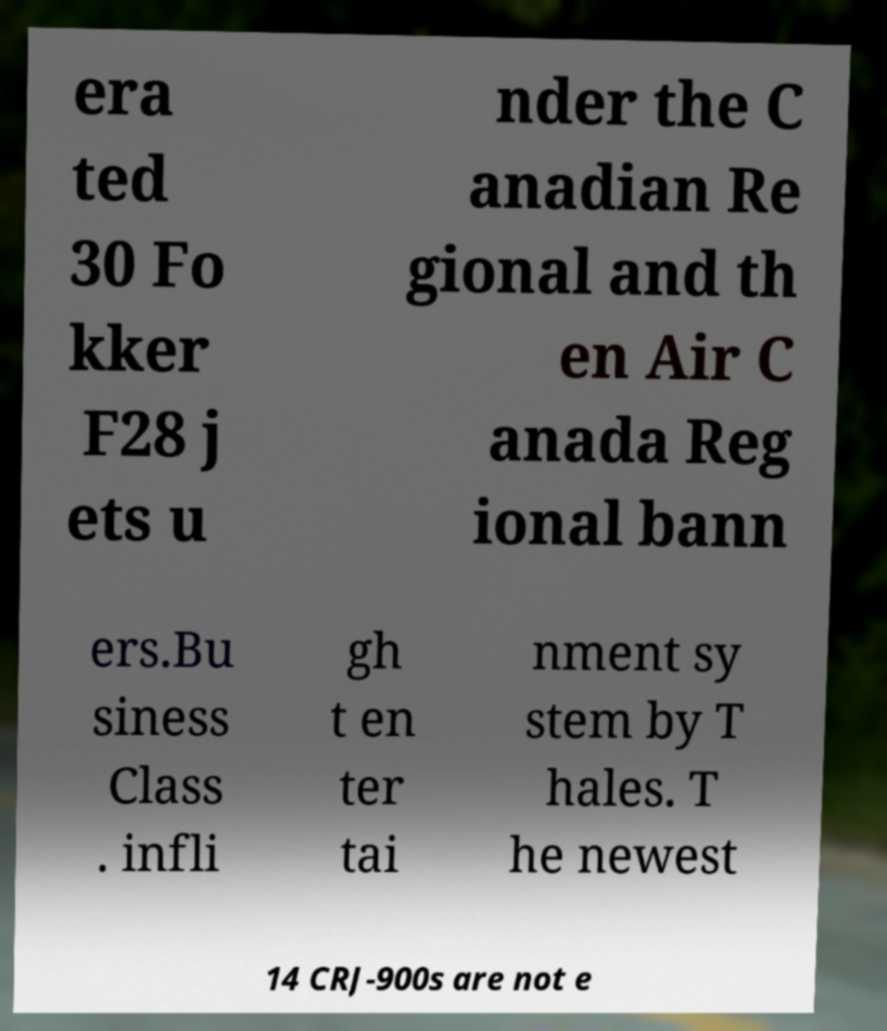Could you assist in decoding the text presented in this image and type it out clearly? era ted 30 Fo kker F28 j ets u nder the C anadian Re gional and th en Air C anada Reg ional bann ers.Bu siness Class . infli gh t en ter tai nment sy stem by T hales. T he newest 14 CRJ-900s are not e 